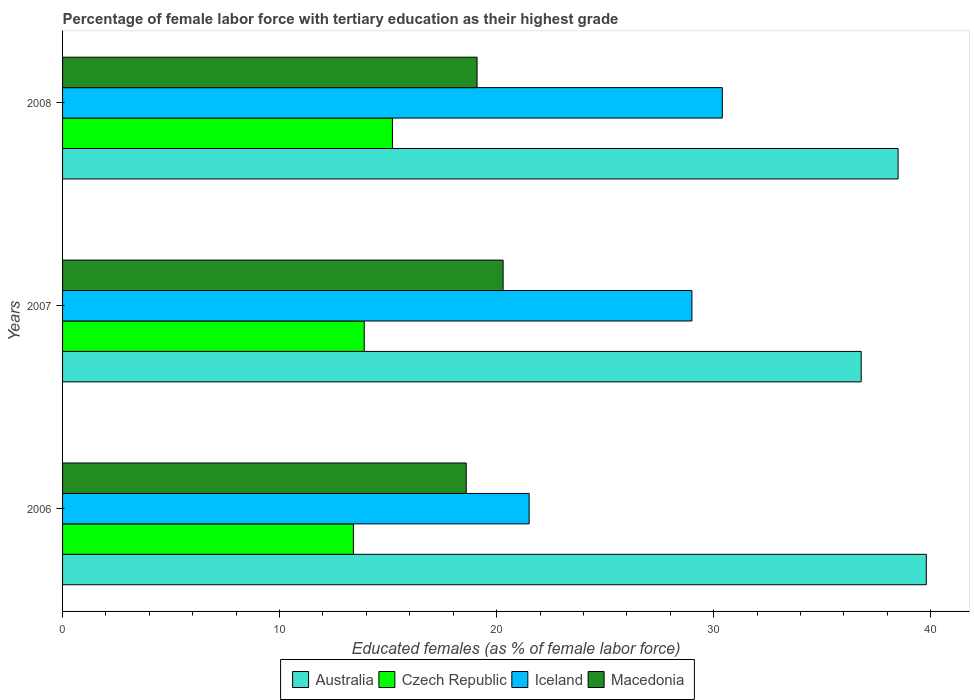How many bars are there on the 3rd tick from the top?
Offer a very short reply. 4. What is the label of the 1st group of bars from the top?
Ensure brevity in your answer.  2008. In how many cases, is the number of bars for a given year not equal to the number of legend labels?
Provide a short and direct response. 0. What is the percentage of female labor force with tertiary education in Macedonia in 2008?
Provide a short and direct response. 19.1. Across all years, what is the maximum percentage of female labor force with tertiary education in Iceland?
Provide a succinct answer. 30.4. Across all years, what is the minimum percentage of female labor force with tertiary education in Macedonia?
Your response must be concise. 18.6. In which year was the percentage of female labor force with tertiary education in Iceland maximum?
Provide a short and direct response. 2008. What is the total percentage of female labor force with tertiary education in Iceland in the graph?
Provide a short and direct response. 80.9. What is the difference between the percentage of female labor force with tertiary education in Iceland in 2006 and that in 2008?
Offer a terse response. -8.9. What is the average percentage of female labor force with tertiary education in Australia per year?
Ensure brevity in your answer.  38.37. In the year 2007, what is the difference between the percentage of female labor force with tertiary education in Czech Republic and percentage of female labor force with tertiary education in Australia?
Offer a terse response. -22.9. In how many years, is the percentage of female labor force with tertiary education in Czech Republic greater than 2 %?
Your response must be concise. 3. What is the ratio of the percentage of female labor force with tertiary education in Iceland in 2006 to that in 2007?
Make the answer very short. 0.74. Is the difference between the percentage of female labor force with tertiary education in Czech Republic in 2006 and 2008 greater than the difference between the percentage of female labor force with tertiary education in Australia in 2006 and 2008?
Your answer should be compact. No. What is the difference between the highest and the second highest percentage of female labor force with tertiary education in Czech Republic?
Provide a succinct answer. 1.3. What is the difference between the highest and the lowest percentage of female labor force with tertiary education in Macedonia?
Give a very brief answer. 1.7. Is the sum of the percentage of female labor force with tertiary education in Iceland in 2006 and 2007 greater than the maximum percentage of female labor force with tertiary education in Macedonia across all years?
Ensure brevity in your answer.  Yes. What does the 3rd bar from the top in 2008 represents?
Ensure brevity in your answer.  Czech Republic. What does the 1st bar from the bottom in 2008 represents?
Your answer should be very brief. Australia. Are all the bars in the graph horizontal?
Offer a very short reply. Yes. How many years are there in the graph?
Give a very brief answer. 3. What is the difference between two consecutive major ticks on the X-axis?
Keep it short and to the point. 10. Does the graph contain grids?
Provide a succinct answer. No. Where does the legend appear in the graph?
Ensure brevity in your answer.  Bottom center. How are the legend labels stacked?
Offer a terse response. Horizontal. What is the title of the graph?
Ensure brevity in your answer.  Percentage of female labor force with tertiary education as their highest grade. What is the label or title of the X-axis?
Your answer should be compact. Educated females (as % of female labor force). What is the label or title of the Y-axis?
Offer a terse response. Years. What is the Educated females (as % of female labor force) in Australia in 2006?
Your answer should be very brief. 39.8. What is the Educated females (as % of female labor force) of Czech Republic in 2006?
Offer a very short reply. 13.4. What is the Educated females (as % of female labor force) of Macedonia in 2006?
Keep it short and to the point. 18.6. What is the Educated females (as % of female labor force) of Australia in 2007?
Your answer should be compact. 36.8. What is the Educated females (as % of female labor force) of Czech Republic in 2007?
Your answer should be very brief. 13.9. What is the Educated females (as % of female labor force) in Macedonia in 2007?
Offer a very short reply. 20.3. What is the Educated females (as % of female labor force) in Australia in 2008?
Provide a succinct answer. 38.5. What is the Educated females (as % of female labor force) in Czech Republic in 2008?
Make the answer very short. 15.2. What is the Educated females (as % of female labor force) of Iceland in 2008?
Keep it short and to the point. 30.4. What is the Educated females (as % of female labor force) of Macedonia in 2008?
Offer a terse response. 19.1. Across all years, what is the maximum Educated females (as % of female labor force) of Australia?
Make the answer very short. 39.8. Across all years, what is the maximum Educated females (as % of female labor force) in Czech Republic?
Your answer should be compact. 15.2. Across all years, what is the maximum Educated females (as % of female labor force) in Iceland?
Provide a short and direct response. 30.4. Across all years, what is the maximum Educated females (as % of female labor force) in Macedonia?
Your answer should be very brief. 20.3. Across all years, what is the minimum Educated females (as % of female labor force) of Australia?
Your answer should be compact. 36.8. Across all years, what is the minimum Educated females (as % of female labor force) in Czech Republic?
Offer a terse response. 13.4. Across all years, what is the minimum Educated females (as % of female labor force) in Iceland?
Make the answer very short. 21.5. Across all years, what is the minimum Educated females (as % of female labor force) of Macedonia?
Provide a short and direct response. 18.6. What is the total Educated females (as % of female labor force) of Australia in the graph?
Ensure brevity in your answer.  115.1. What is the total Educated females (as % of female labor force) of Czech Republic in the graph?
Your answer should be very brief. 42.5. What is the total Educated females (as % of female labor force) in Iceland in the graph?
Your answer should be very brief. 80.9. What is the difference between the Educated females (as % of female labor force) in Macedonia in 2006 and that in 2007?
Provide a short and direct response. -1.7. What is the difference between the Educated females (as % of female labor force) of Czech Republic in 2006 and that in 2008?
Provide a succinct answer. -1.8. What is the difference between the Educated females (as % of female labor force) of Iceland in 2006 and that in 2008?
Provide a short and direct response. -8.9. What is the difference between the Educated females (as % of female labor force) of Australia in 2007 and that in 2008?
Offer a terse response. -1.7. What is the difference between the Educated females (as % of female labor force) of Czech Republic in 2007 and that in 2008?
Offer a terse response. -1.3. What is the difference between the Educated females (as % of female labor force) in Iceland in 2007 and that in 2008?
Your answer should be compact. -1.4. What is the difference between the Educated females (as % of female labor force) in Australia in 2006 and the Educated females (as % of female labor force) in Czech Republic in 2007?
Provide a short and direct response. 25.9. What is the difference between the Educated females (as % of female labor force) in Australia in 2006 and the Educated females (as % of female labor force) in Iceland in 2007?
Ensure brevity in your answer.  10.8. What is the difference between the Educated females (as % of female labor force) of Australia in 2006 and the Educated females (as % of female labor force) of Macedonia in 2007?
Offer a very short reply. 19.5. What is the difference between the Educated females (as % of female labor force) of Czech Republic in 2006 and the Educated females (as % of female labor force) of Iceland in 2007?
Keep it short and to the point. -15.6. What is the difference between the Educated females (as % of female labor force) in Australia in 2006 and the Educated females (as % of female labor force) in Czech Republic in 2008?
Your answer should be compact. 24.6. What is the difference between the Educated females (as % of female labor force) in Australia in 2006 and the Educated females (as % of female labor force) in Macedonia in 2008?
Keep it short and to the point. 20.7. What is the difference between the Educated females (as % of female labor force) in Iceland in 2006 and the Educated females (as % of female labor force) in Macedonia in 2008?
Your answer should be very brief. 2.4. What is the difference between the Educated females (as % of female labor force) in Australia in 2007 and the Educated females (as % of female labor force) in Czech Republic in 2008?
Give a very brief answer. 21.6. What is the difference between the Educated females (as % of female labor force) of Australia in 2007 and the Educated females (as % of female labor force) of Iceland in 2008?
Provide a succinct answer. 6.4. What is the difference between the Educated females (as % of female labor force) of Australia in 2007 and the Educated females (as % of female labor force) of Macedonia in 2008?
Your response must be concise. 17.7. What is the difference between the Educated females (as % of female labor force) in Czech Republic in 2007 and the Educated females (as % of female labor force) in Iceland in 2008?
Your response must be concise. -16.5. What is the average Educated females (as % of female labor force) of Australia per year?
Ensure brevity in your answer.  38.37. What is the average Educated females (as % of female labor force) in Czech Republic per year?
Provide a succinct answer. 14.17. What is the average Educated females (as % of female labor force) of Iceland per year?
Your answer should be very brief. 26.97. What is the average Educated females (as % of female labor force) of Macedonia per year?
Keep it short and to the point. 19.33. In the year 2006, what is the difference between the Educated females (as % of female labor force) in Australia and Educated females (as % of female labor force) in Czech Republic?
Keep it short and to the point. 26.4. In the year 2006, what is the difference between the Educated females (as % of female labor force) in Australia and Educated females (as % of female labor force) in Macedonia?
Provide a short and direct response. 21.2. In the year 2006, what is the difference between the Educated females (as % of female labor force) of Czech Republic and Educated females (as % of female labor force) of Iceland?
Provide a short and direct response. -8.1. In the year 2007, what is the difference between the Educated females (as % of female labor force) of Australia and Educated females (as % of female labor force) of Czech Republic?
Ensure brevity in your answer.  22.9. In the year 2007, what is the difference between the Educated females (as % of female labor force) in Australia and Educated females (as % of female labor force) in Iceland?
Your answer should be compact. 7.8. In the year 2007, what is the difference between the Educated females (as % of female labor force) of Australia and Educated females (as % of female labor force) of Macedonia?
Your answer should be compact. 16.5. In the year 2007, what is the difference between the Educated females (as % of female labor force) of Czech Republic and Educated females (as % of female labor force) of Iceland?
Ensure brevity in your answer.  -15.1. In the year 2007, what is the difference between the Educated females (as % of female labor force) in Czech Republic and Educated females (as % of female labor force) in Macedonia?
Provide a succinct answer. -6.4. In the year 2007, what is the difference between the Educated females (as % of female labor force) of Iceland and Educated females (as % of female labor force) of Macedonia?
Make the answer very short. 8.7. In the year 2008, what is the difference between the Educated females (as % of female labor force) in Australia and Educated females (as % of female labor force) in Czech Republic?
Offer a very short reply. 23.3. In the year 2008, what is the difference between the Educated females (as % of female labor force) of Australia and Educated females (as % of female labor force) of Iceland?
Offer a terse response. 8.1. In the year 2008, what is the difference between the Educated females (as % of female labor force) in Australia and Educated females (as % of female labor force) in Macedonia?
Provide a short and direct response. 19.4. In the year 2008, what is the difference between the Educated females (as % of female labor force) in Czech Republic and Educated females (as % of female labor force) in Iceland?
Offer a terse response. -15.2. What is the ratio of the Educated females (as % of female labor force) of Australia in 2006 to that in 2007?
Offer a terse response. 1.08. What is the ratio of the Educated females (as % of female labor force) in Iceland in 2006 to that in 2007?
Your response must be concise. 0.74. What is the ratio of the Educated females (as % of female labor force) in Macedonia in 2006 to that in 2007?
Ensure brevity in your answer.  0.92. What is the ratio of the Educated females (as % of female labor force) of Australia in 2006 to that in 2008?
Ensure brevity in your answer.  1.03. What is the ratio of the Educated females (as % of female labor force) in Czech Republic in 2006 to that in 2008?
Your answer should be very brief. 0.88. What is the ratio of the Educated females (as % of female labor force) of Iceland in 2006 to that in 2008?
Make the answer very short. 0.71. What is the ratio of the Educated females (as % of female labor force) of Macedonia in 2006 to that in 2008?
Your answer should be very brief. 0.97. What is the ratio of the Educated females (as % of female labor force) in Australia in 2007 to that in 2008?
Your answer should be compact. 0.96. What is the ratio of the Educated females (as % of female labor force) in Czech Republic in 2007 to that in 2008?
Provide a short and direct response. 0.91. What is the ratio of the Educated females (as % of female labor force) in Iceland in 2007 to that in 2008?
Your answer should be compact. 0.95. What is the ratio of the Educated females (as % of female labor force) in Macedonia in 2007 to that in 2008?
Offer a terse response. 1.06. What is the difference between the highest and the second highest Educated females (as % of female labor force) in Australia?
Give a very brief answer. 1.3. What is the difference between the highest and the second highest Educated females (as % of female labor force) in Czech Republic?
Make the answer very short. 1.3. What is the difference between the highest and the second highest Educated females (as % of female labor force) in Macedonia?
Your answer should be compact. 1.2. What is the difference between the highest and the lowest Educated females (as % of female labor force) in Czech Republic?
Offer a very short reply. 1.8. What is the difference between the highest and the lowest Educated females (as % of female labor force) in Iceland?
Offer a terse response. 8.9. What is the difference between the highest and the lowest Educated females (as % of female labor force) in Macedonia?
Give a very brief answer. 1.7. 